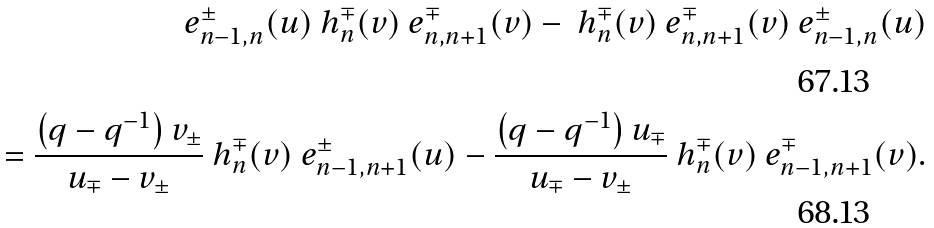Convert formula to latex. <formula><loc_0><loc_0><loc_500><loc_500>\ e _ { n - 1 , n } ^ { \pm } ( u ) \ h ^ { \mp } _ { n } ( v ) \ e _ { n , n + 1 } ^ { \mp } ( v ) - \ h ^ { \mp } _ { n } ( v ) \ e _ { n , n + 1 } ^ { \mp } ( v ) \ e _ { n - 1 , n } ^ { \pm } ( u ) \\ = \frac { \left ( q - q ^ { - 1 } \right ) v _ { \pm } } { u _ { \mp } - v _ { \pm } } \ h ^ { \mp } _ { n } ( v ) \ e _ { n - 1 , n + 1 } ^ { \pm } ( u ) - \frac { \left ( q - q ^ { - 1 } \right ) u _ { \mp } } { u _ { \mp } - v _ { \pm } } \ h ^ { \mp } _ { n } ( v ) \ e _ { n - 1 , n + 1 } ^ { \mp } ( v ) .</formula> 